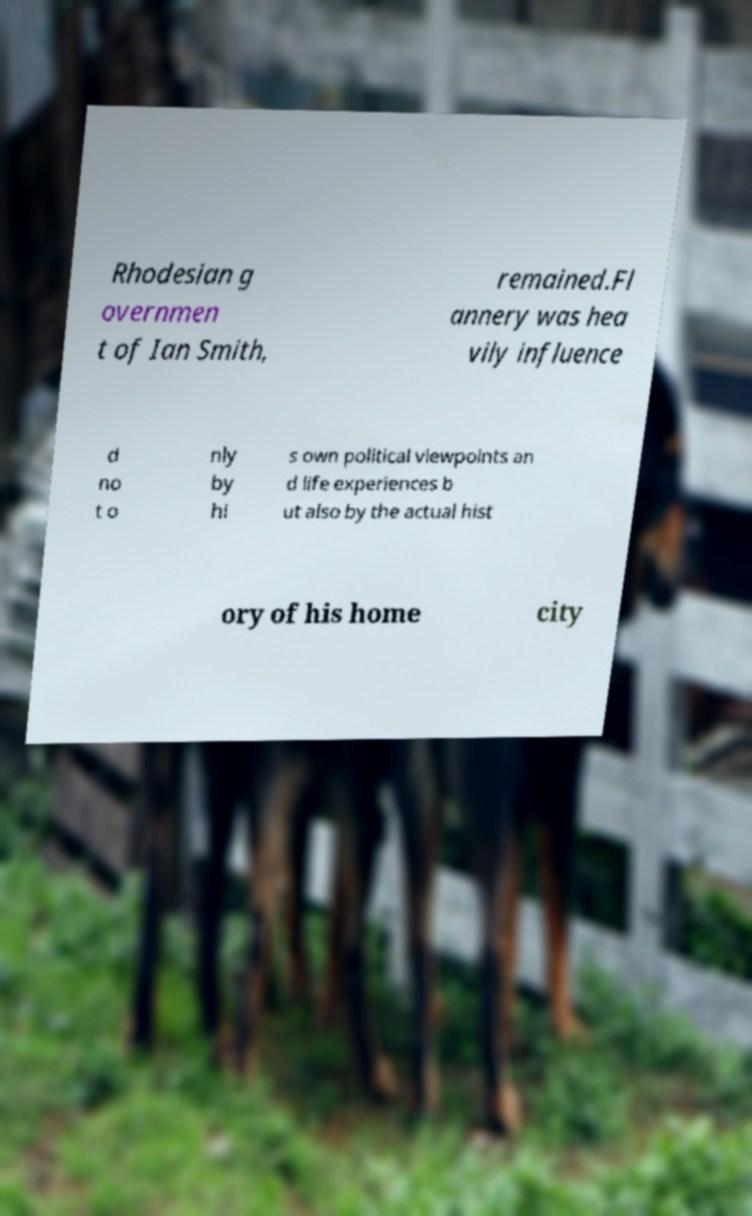Could you extract and type out the text from this image? Rhodesian g overnmen t of Ian Smith, remained.Fl annery was hea vily influence d no t o nly by hi s own political viewpoints an d life experiences b ut also by the actual hist ory of his home city 